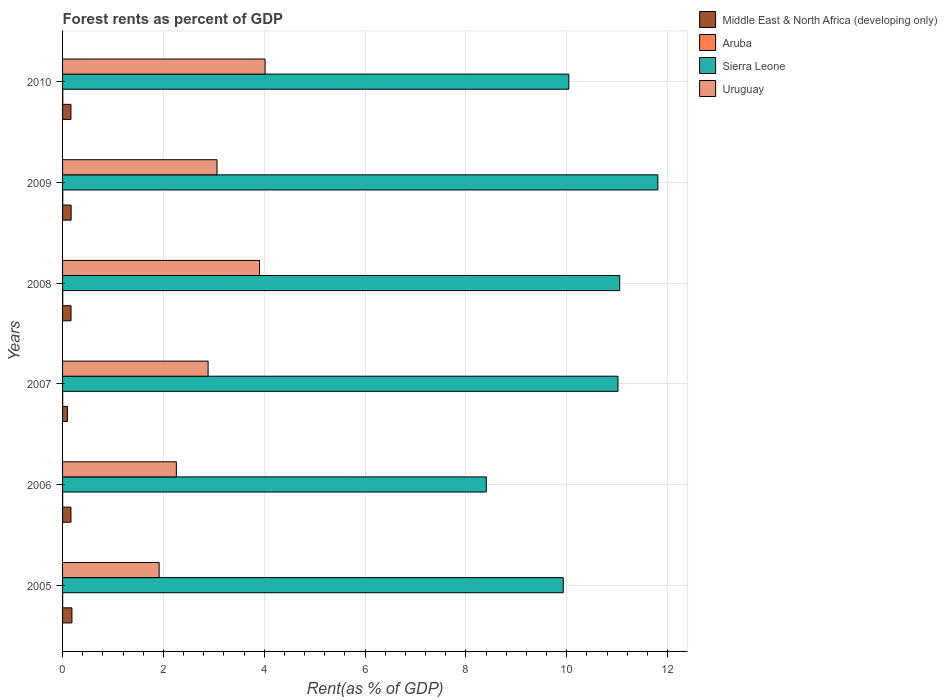Are the number of bars on each tick of the Y-axis equal?
Your answer should be compact. Yes. What is the label of the 5th group of bars from the top?
Ensure brevity in your answer.  2006. In how many cases, is the number of bars for a given year not equal to the number of legend labels?
Ensure brevity in your answer.  0. What is the forest rent in Middle East & North Africa (developing only) in 2005?
Offer a very short reply. 0.19. Across all years, what is the maximum forest rent in Middle East & North Africa (developing only)?
Your answer should be compact. 0.19. Across all years, what is the minimum forest rent in Uruguay?
Make the answer very short. 1.92. In which year was the forest rent in Middle East & North Africa (developing only) maximum?
Keep it short and to the point. 2005. In which year was the forest rent in Sierra Leone minimum?
Provide a short and direct response. 2006. What is the total forest rent in Aruba in the graph?
Offer a very short reply. 0.02. What is the difference between the forest rent in Sierra Leone in 2005 and that in 2008?
Provide a succinct answer. -1.12. What is the difference between the forest rent in Uruguay in 2006 and the forest rent in Sierra Leone in 2009?
Keep it short and to the point. -9.55. What is the average forest rent in Middle East & North Africa (developing only) per year?
Offer a terse response. 0.16. In the year 2005, what is the difference between the forest rent in Uruguay and forest rent in Sierra Leone?
Keep it short and to the point. -8.02. In how many years, is the forest rent in Sierra Leone greater than 9.2 %?
Make the answer very short. 5. What is the ratio of the forest rent in Middle East & North Africa (developing only) in 2006 to that in 2010?
Provide a short and direct response. 1. What is the difference between the highest and the second highest forest rent in Uruguay?
Offer a terse response. 0.11. What is the difference between the highest and the lowest forest rent in Uruguay?
Offer a very short reply. 2.1. In how many years, is the forest rent in Sierra Leone greater than the average forest rent in Sierra Leone taken over all years?
Ensure brevity in your answer.  3. What does the 4th bar from the top in 2006 represents?
Your answer should be compact. Middle East & North Africa (developing only). What does the 3rd bar from the bottom in 2008 represents?
Your answer should be very brief. Sierra Leone. How many bars are there?
Your answer should be very brief. 24. Are all the bars in the graph horizontal?
Offer a terse response. Yes. Are the values on the major ticks of X-axis written in scientific E-notation?
Your answer should be compact. No. Does the graph contain grids?
Offer a terse response. Yes. How many legend labels are there?
Make the answer very short. 4. What is the title of the graph?
Your response must be concise. Forest rents as percent of GDP. Does "Comoros" appear as one of the legend labels in the graph?
Offer a terse response. No. What is the label or title of the X-axis?
Give a very brief answer. Rent(as % of GDP). What is the label or title of the Y-axis?
Offer a terse response. Years. What is the Rent(as % of GDP) in Middle East & North Africa (developing only) in 2005?
Make the answer very short. 0.19. What is the Rent(as % of GDP) in Aruba in 2005?
Your response must be concise. 0. What is the Rent(as % of GDP) in Sierra Leone in 2005?
Offer a very short reply. 9.93. What is the Rent(as % of GDP) in Uruguay in 2005?
Your answer should be very brief. 1.92. What is the Rent(as % of GDP) in Middle East & North Africa (developing only) in 2006?
Provide a succinct answer. 0.17. What is the Rent(as % of GDP) in Aruba in 2006?
Provide a succinct answer. 0. What is the Rent(as % of GDP) of Sierra Leone in 2006?
Your answer should be very brief. 8.41. What is the Rent(as % of GDP) in Uruguay in 2006?
Provide a short and direct response. 2.26. What is the Rent(as % of GDP) in Middle East & North Africa (developing only) in 2007?
Keep it short and to the point. 0.1. What is the Rent(as % of GDP) in Aruba in 2007?
Provide a succinct answer. 0. What is the Rent(as % of GDP) in Sierra Leone in 2007?
Ensure brevity in your answer.  11.02. What is the Rent(as % of GDP) in Uruguay in 2007?
Ensure brevity in your answer.  2.89. What is the Rent(as % of GDP) in Middle East & North Africa (developing only) in 2008?
Your answer should be compact. 0.17. What is the Rent(as % of GDP) in Aruba in 2008?
Your answer should be compact. 0. What is the Rent(as % of GDP) of Sierra Leone in 2008?
Ensure brevity in your answer.  11.05. What is the Rent(as % of GDP) in Uruguay in 2008?
Your answer should be very brief. 3.91. What is the Rent(as % of GDP) in Middle East & North Africa (developing only) in 2009?
Provide a succinct answer. 0.17. What is the Rent(as % of GDP) of Aruba in 2009?
Your answer should be very brief. 0. What is the Rent(as % of GDP) of Sierra Leone in 2009?
Keep it short and to the point. 11.81. What is the Rent(as % of GDP) of Uruguay in 2009?
Provide a short and direct response. 3.06. What is the Rent(as % of GDP) of Middle East & North Africa (developing only) in 2010?
Your response must be concise. 0.17. What is the Rent(as % of GDP) in Aruba in 2010?
Keep it short and to the point. 0. What is the Rent(as % of GDP) in Sierra Leone in 2010?
Ensure brevity in your answer.  10.04. What is the Rent(as % of GDP) of Uruguay in 2010?
Ensure brevity in your answer.  4.02. Across all years, what is the maximum Rent(as % of GDP) of Middle East & North Africa (developing only)?
Give a very brief answer. 0.19. Across all years, what is the maximum Rent(as % of GDP) of Aruba?
Your answer should be very brief. 0. Across all years, what is the maximum Rent(as % of GDP) in Sierra Leone?
Keep it short and to the point. 11.81. Across all years, what is the maximum Rent(as % of GDP) of Uruguay?
Ensure brevity in your answer.  4.02. Across all years, what is the minimum Rent(as % of GDP) in Middle East & North Africa (developing only)?
Offer a terse response. 0.1. Across all years, what is the minimum Rent(as % of GDP) in Aruba?
Give a very brief answer. 0. Across all years, what is the minimum Rent(as % of GDP) of Sierra Leone?
Keep it short and to the point. 8.41. Across all years, what is the minimum Rent(as % of GDP) of Uruguay?
Ensure brevity in your answer.  1.92. What is the total Rent(as % of GDP) of Middle East & North Africa (developing only) in the graph?
Ensure brevity in your answer.  0.95. What is the total Rent(as % of GDP) of Aruba in the graph?
Your answer should be very brief. 0.02. What is the total Rent(as % of GDP) in Sierra Leone in the graph?
Keep it short and to the point. 62.26. What is the total Rent(as % of GDP) of Uruguay in the graph?
Provide a succinct answer. 18.05. What is the difference between the Rent(as % of GDP) in Middle East & North Africa (developing only) in 2005 and that in 2006?
Provide a short and direct response. 0.02. What is the difference between the Rent(as % of GDP) of Aruba in 2005 and that in 2006?
Your answer should be very brief. -0. What is the difference between the Rent(as % of GDP) in Sierra Leone in 2005 and that in 2006?
Keep it short and to the point. 1.53. What is the difference between the Rent(as % of GDP) in Uruguay in 2005 and that in 2006?
Your answer should be very brief. -0.34. What is the difference between the Rent(as % of GDP) in Middle East & North Africa (developing only) in 2005 and that in 2007?
Your answer should be compact. 0.09. What is the difference between the Rent(as % of GDP) of Aruba in 2005 and that in 2007?
Your answer should be very brief. -0. What is the difference between the Rent(as % of GDP) in Sierra Leone in 2005 and that in 2007?
Offer a very short reply. -1.09. What is the difference between the Rent(as % of GDP) in Uruguay in 2005 and that in 2007?
Provide a short and direct response. -0.97. What is the difference between the Rent(as % of GDP) of Middle East & North Africa (developing only) in 2005 and that in 2008?
Ensure brevity in your answer.  0.02. What is the difference between the Rent(as % of GDP) of Aruba in 2005 and that in 2008?
Provide a succinct answer. -0. What is the difference between the Rent(as % of GDP) in Sierra Leone in 2005 and that in 2008?
Your answer should be very brief. -1.12. What is the difference between the Rent(as % of GDP) in Uruguay in 2005 and that in 2008?
Your answer should be compact. -1.99. What is the difference between the Rent(as % of GDP) of Middle East & North Africa (developing only) in 2005 and that in 2009?
Your answer should be very brief. 0.02. What is the difference between the Rent(as % of GDP) in Aruba in 2005 and that in 2009?
Give a very brief answer. -0. What is the difference between the Rent(as % of GDP) of Sierra Leone in 2005 and that in 2009?
Offer a terse response. -1.88. What is the difference between the Rent(as % of GDP) in Uruguay in 2005 and that in 2009?
Give a very brief answer. -1.15. What is the difference between the Rent(as % of GDP) in Middle East & North Africa (developing only) in 2005 and that in 2010?
Give a very brief answer. 0.02. What is the difference between the Rent(as % of GDP) in Aruba in 2005 and that in 2010?
Your response must be concise. -0. What is the difference between the Rent(as % of GDP) in Sierra Leone in 2005 and that in 2010?
Provide a short and direct response. -0.11. What is the difference between the Rent(as % of GDP) of Uruguay in 2005 and that in 2010?
Give a very brief answer. -2.1. What is the difference between the Rent(as % of GDP) in Middle East & North Africa (developing only) in 2006 and that in 2007?
Provide a succinct answer. 0.07. What is the difference between the Rent(as % of GDP) in Aruba in 2006 and that in 2007?
Ensure brevity in your answer.  -0. What is the difference between the Rent(as % of GDP) of Sierra Leone in 2006 and that in 2007?
Make the answer very short. -2.61. What is the difference between the Rent(as % of GDP) of Uruguay in 2006 and that in 2007?
Ensure brevity in your answer.  -0.63. What is the difference between the Rent(as % of GDP) of Middle East & North Africa (developing only) in 2006 and that in 2008?
Give a very brief answer. -0. What is the difference between the Rent(as % of GDP) of Aruba in 2006 and that in 2008?
Offer a terse response. -0. What is the difference between the Rent(as % of GDP) in Sierra Leone in 2006 and that in 2008?
Make the answer very short. -2.65. What is the difference between the Rent(as % of GDP) of Uruguay in 2006 and that in 2008?
Offer a very short reply. -1.65. What is the difference between the Rent(as % of GDP) in Middle East & North Africa (developing only) in 2006 and that in 2009?
Keep it short and to the point. -0. What is the difference between the Rent(as % of GDP) of Aruba in 2006 and that in 2009?
Provide a short and direct response. -0. What is the difference between the Rent(as % of GDP) in Sierra Leone in 2006 and that in 2009?
Ensure brevity in your answer.  -3.4. What is the difference between the Rent(as % of GDP) in Uruguay in 2006 and that in 2009?
Make the answer very short. -0.81. What is the difference between the Rent(as % of GDP) of Aruba in 2006 and that in 2010?
Ensure brevity in your answer.  -0. What is the difference between the Rent(as % of GDP) of Sierra Leone in 2006 and that in 2010?
Your answer should be very brief. -1.64. What is the difference between the Rent(as % of GDP) of Uruguay in 2006 and that in 2010?
Provide a short and direct response. -1.76. What is the difference between the Rent(as % of GDP) in Middle East & North Africa (developing only) in 2007 and that in 2008?
Your answer should be very brief. -0.07. What is the difference between the Rent(as % of GDP) of Aruba in 2007 and that in 2008?
Your answer should be very brief. -0. What is the difference between the Rent(as % of GDP) in Sierra Leone in 2007 and that in 2008?
Offer a terse response. -0.03. What is the difference between the Rent(as % of GDP) of Uruguay in 2007 and that in 2008?
Provide a short and direct response. -1.02. What is the difference between the Rent(as % of GDP) of Middle East & North Africa (developing only) in 2007 and that in 2009?
Keep it short and to the point. -0.07. What is the difference between the Rent(as % of GDP) of Aruba in 2007 and that in 2009?
Ensure brevity in your answer.  -0. What is the difference between the Rent(as % of GDP) in Sierra Leone in 2007 and that in 2009?
Keep it short and to the point. -0.79. What is the difference between the Rent(as % of GDP) of Uruguay in 2007 and that in 2009?
Offer a very short reply. -0.18. What is the difference between the Rent(as % of GDP) of Middle East & North Africa (developing only) in 2007 and that in 2010?
Provide a short and direct response. -0.07. What is the difference between the Rent(as % of GDP) of Aruba in 2007 and that in 2010?
Your response must be concise. -0. What is the difference between the Rent(as % of GDP) in Sierra Leone in 2007 and that in 2010?
Your answer should be compact. 0.98. What is the difference between the Rent(as % of GDP) in Uruguay in 2007 and that in 2010?
Provide a short and direct response. -1.13. What is the difference between the Rent(as % of GDP) in Middle East & North Africa (developing only) in 2008 and that in 2009?
Your answer should be compact. -0. What is the difference between the Rent(as % of GDP) of Aruba in 2008 and that in 2009?
Your answer should be very brief. -0. What is the difference between the Rent(as % of GDP) in Sierra Leone in 2008 and that in 2009?
Provide a short and direct response. -0.76. What is the difference between the Rent(as % of GDP) of Uruguay in 2008 and that in 2009?
Provide a succinct answer. 0.84. What is the difference between the Rent(as % of GDP) of Middle East & North Africa (developing only) in 2008 and that in 2010?
Keep it short and to the point. 0. What is the difference between the Rent(as % of GDP) in Aruba in 2008 and that in 2010?
Give a very brief answer. -0. What is the difference between the Rent(as % of GDP) in Sierra Leone in 2008 and that in 2010?
Keep it short and to the point. 1.01. What is the difference between the Rent(as % of GDP) of Uruguay in 2008 and that in 2010?
Give a very brief answer. -0.11. What is the difference between the Rent(as % of GDP) in Middle East & North Africa (developing only) in 2009 and that in 2010?
Your response must be concise. 0. What is the difference between the Rent(as % of GDP) in Aruba in 2009 and that in 2010?
Provide a succinct answer. -0. What is the difference between the Rent(as % of GDP) in Sierra Leone in 2009 and that in 2010?
Ensure brevity in your answer.  1.77. What is the difference between the Rent(as % of GDP) of Uruguay in 2009 and that in 2010?
Keep it short and to the point. -0.95. What is the difference between the Rent(as % of GDP) in Middle East & North Africa (developing only) in 2005 and the Rent(as % of GDP) in Aruba in 2006?
Your response must be concise. 0.18. What is the difference between the Rent(as % of GDP) in Middle East & North Africa (developing only) in 2005 and the Rent(as % of GDP) in Sierra Leone in 2006?
Give a very brief answer. -8.22. What is the difference between the Rent(as % of GDP) in Middle East & North Africa (developing only) in 2005 and the Rent(as % of GDP) in Uruguay in 2006?
Give a very brief answer. -2.07. What is the difference between the Rent(as % of GDP) in Aruba in 2005 and the Rent(as % of GDP) in Sierra Leone in 2006?
Offer a very short reply. -8.4. What is the difference between the Rent(as % of GDP) in Aruba in 2005 and the Rent(as % of GDP) in Uruguay in 2006?
Your answer should be very brief. -2.26. What is the difference between the Rent(as % of GDP) in Sierra Leone in 2005 and the Rent(as % of GDP) in Uruguay in 2006?
Make the answer very short. 7.68. What is the difference between the Rent(as % of GDP) in Middle East & North Africa (developing only) in 2005 and the Rent(as % of GDP) in Aruba in 2007?
Provide a succinct answer. 0.18. What is the difference between the Rent(as % of GDP) of Middle East & North Africa (developing only) in 2005 and the Rent(as % of GDP) of Sierra Leone in 2007?
Make the answer very short. -10.83. What is the difference between the Rent(as % of GDP) in Middle East & North Africa (developing only) in 2005 and the Rent(as % of GDP) in Uruguay in 2007?
Make the answer very short. -2.7. What is the difference between the Rent(as % of GDP) of Aruba in 2005 and the Rent(as % of GDP) of Sierra Leone in 2007?
Keep it short and to the point. -11.02. What is the difference between the Rent(as % of GDP) of Aruba in 2005 and the Rent(as % of GDP) of Uruguay in 2007?
Your response must be concise. -2.89. What is the difference between the Rent(as % of GDP) in Sierra Leone in 2005 and the Rent(as % of GDP) in Uruguay in 2007?
Give a very brief answer. 7.05. What is the difference between the Rent(as % of GDP) in Middle East & North Africa (developing only) in 2005 and the Rent(as % of GDP) in Aruba in 2008?
Your answer should be compact. 0.18. What is the difference between the Rent(as % of GDP) in Middle East & North Africa (developing only) in 2005 and the Rent(as % of GDP) in Sierra Leone in 2008?
Your answer should be very brief. -10.87. What is the difference between the Rent(as % of GDP) of Middle East & North Africa (developing only) in 2005 and the Rent(as % of GDP) of Uruguay in 2008?
Offer a terse response. -3.72. What is the difference between the Rent(as % of GDP) of Aruba in 2005 and the Rent(as % of GDP) of Sierra Leone in 2008?
Your response must be concise. -11.05. What is the difference between the Rent(as % of GDP) in Aruba in 2005 and the Rent(as % of GDP) in Uruguay in 2008?
Give a very brief answer. -3.91. What is the difference between the Rent(as % of GDP) of Sierra Leone in 2005 and the Rent(as % of GDP) of Uruguay in 2008?
Your response must be concise. 6.03. What is the difference between the Rent(as % of GDP) of Middle East & North Africa (developing only) in 2005 and the Rent(as % of GDP) of Aruba in 2009?
Give a very brief answer. 0.18. What is the difference between the Rent(as % of GDP) in Middle East & North Africa (developing only) in 2005 and the Rent(as % of GDP) in Sierra Leone in 2009?
Offer a very short reply. -11.62. What is the difference between the Rent(as % of GDP) in Middle East & North Africa (developing only) in 2005 and the Rent(as % of GDP) in Uruguay in 2009?
Provide a succinct answer. -2.88. What is the difference between the Rent(as % of GDP) in Aruba in 2005 and the Rent(as % of GDP) in Sierra Leone in 2009?
Provide a short and direct response. -11.81. What is the difference between the Rent(as % of GDP) of Aruba in 2005 and the Rent(as % of GDP) of Uruguay in 2009?
Provide a short and direct response. -3.06. What is the difference between the Rent(as % of GDP) of Sierra Leone in 2005 and the Rent(as % of GDP) of Uruguay in 2009?
Offer a very short reply. 6.87. What is the difference between the Rent(as % of GDP) of Middle East & North Africa (developing only) in 2005 and the Rent(as % of GDP) of Aruba in 2010?
Offer a very short reply. 0.18. What is the difference between the Rent(as % of GDP) of Middle East & North Africa (developing only) in 2005 and the Rent(as % of GDP) of Sierra Leone in 2010?
Your answer should be very brief. -9.86. What is the difference between the Rent(as % of GDP) of Middle East & North Africa (developing only) in 2005 and the Rent(as % of GDP) of Uruguay in 2010?
Provide a succinct answer. -3.83. What is the difference between the Rent(as % of GDP) of Aruba in 2005 and the Rent(as % of GDP) of Sierra Leone in 2010?
Your answer should be very brief. -10.04. What is the difference between the Rent(as % of GDP) in Aruba in 2005 and the Rent(as % of GDP) in Uruguay in 2010?
Make the answer very short. -4.02. What is the difference between the Rent(as % of GDP) of Sierra Leone in 2005 and the Rent(as % of GDP) of Uruguay in 2010?
Ensure brevity in your answer.  5.92. What is the difference between the Rent(as % of GDP) in Middle East & North Africa (developing only) in 2006 and the Rent(as % of GDP) in Aruba in 2007?
Keep it short and to the point. 0.16. What is the difference between the Rent(as % of GDP) in Middle East & North Africa (developing only) in 2006 and the Rent(as % of GDP) in Sierra Leone in 2007?
Provide a succinct answer. -10.85. What is the difference between the Rent(as % of GDP) of Middle East & North Africa (developing only) in 2006 and the Rent(as % of GDP) of Uruguay in 2007?
Make the answer very short. -2.72. What is the difference between the Rent(as % of GDP) of Aruba in 2006 and the Rent(as % of GDP) of Sierra Leone in 2007?
Offer a terse response. -11.02. What is the difference between the Rent(as % of GDP) of Aruba in 2006 and the Rent(as % of GDP) of Uruguay in 2007?
Your response must be concise. -2.89. What is the difference between the Rent(as % of GDP) of Sierra Leone in 2006 and the Rent(as % of GDP) of Uruguay in 2007?
Give a very brief answer. 5.52. What is the difference between the Rent(as % of GDP) of Middle East & North Africa (developing only) in 2006 and the Rent(as % of GDP) of Aruba in 2008?
Your answer should be compact. 0.16. What is the difference between the Rent(as % of GDP) of Middle East & North Africa (developing only) in 2006 and the Rent(as % of GDP) of Sierra Leone in 2008?
Your answer should be compact. -10.89. What is the difference between the Rent(as % of GDP) of Middle East & North Africa (developing only) in 2006 and the Rent(as % of GDP) of Uruguay in 2008?
Your answer should be compact. -3.74. What is the difference between the Rent(as % of GDP) in Aruba in 2006 and the Rent(as % of GDP) in Sierra Leone in 2008?
Make the answer very short. -11.05. What is the difference between the Rent(as % of GDP) in Aruba in 2006 and the Rent(as % of GDP) in Uruguay in 2008?
Provide a succinct answer. -3.9. What is the difference between the Rent(as % of GDP) in Sierra Leone in 2006 and the Rent(as % of GDP) in Uruguay in 2008?
Offer a very short reply. 4.5. What is the difference between the Rent(as % of GDP) in Middle East & North Africa (developing only) in 2006 and the Rent(as % of GDP) in Aruba in 2009?
Keep it short and to the point. 0.16. What is the difference between the Rent(as % of GDP) of Middle East & North Africa (developing only) in 2006 and the Rent(as % of GDP) of Sierra Leone in 2009?
Provide a succinct answer. -11.64. What is the difference between the Rent(as % of GDP) of Middle East & North Africa (developing only) in 2006 and the Rent(as % of GDP) of Uruguay in 2009?
Offer a terse response. -2.9. What is the difference between the Rent(as % of GDP) of Aruba in 2006 and the Rent(as % of GDP) of Sierra Leone in 2009?
Your answer should be compact. -11.81. What is the difference between the Rent(as % of GDP) of Aruba in 2006 and the Rent(as % of GDP) of Uruguay in 2009?
Your response must be concise. -3.06. What is the difference between the Rent(as % of GDP) in Sierra Leone in 2006 and the Rent(as % of GDP) in Uruguay in 2009?
Offer a very short reply. 5.34. What is the difference between the Rent(as % of GDP) of Middle East & North Africa (developing only) in 2006 and the Rent(as % of GDP) of Aruba in 2010?
Ensure brevity in your answer.  0.16. What is the difference between the Rent(as % of GDP) of Middle East & North Africa (developing only) in 2006 and the Rent(as % of GDP) of Sierra Leone in 2010?
Your response must be concise. -9.88. What is the difference between the Rent(as % of GDP) of Middle East & North Africa (developing only) in 2006 and the Rent(as % of GDP) of Uruguay in 2010?
Your answer should be very brief. -3.85. What is the difference between the Rent(as % of GDP) in Aruba in 2006 and the Rent(as % of GDP) in Sierra Leone in 2010?
Provide a short and direct response. -10.04. What is the difference between the Rent(as % of GDP) of Aruba in 2006 and the Rent(as % of GDP) of Uruguay in 2010?
Provide a succinct answer. -4.02. What is the difference between the Rent(as % of GDP) in Sierra Leone in 2006 and the Rent(as % of GDP) in Uruguay in 2010?
Ensure brevity in your answer.  4.39. What is the difference between the Rent(as % of GDP) in Middle East & North Africa (developing only) in 2007 and the Rent(as % of GDP) in Aruba in 2008?
Ensure brevity in your answer.  0.09. What is the difference between the Rent(as % of GDP) in Middle East & North Africa (developing only) in 2007 and the Rent(as % of GDP) in Sierra Leone in 2008?
Offer a terse response. -10.96. What is the difference between the Rent(as % of GDP) of Middle East & North Africa (developing only) in 2007 and the Rent(as % of GDP) of Uruguay in 2008?
Provide a short and direct response. -3.81. What is the difference between the Rent(as % of GDP) in Aruba in 2007 and the Rent(as % of GDP) in Sierra Leone in 2008?
Ensure brevity in your answer.  -11.05. What is the difference between the Rent(as % of GDP) in Aruba in 2007 and the Rent(as % of GDP) in Uruguay in 2008?
Provide a short and direct response. -3.9. What is the difference between the Rent(as % of GDP) in Sierra Leone in 2007 and the Rent(as % of GDP) in Uruguay in 2008?
Offer a terse response. 7.11. What is the difference between the Rent(as % of GDP) in Middle East & North Africa (developing only) in 2007 and the Rent(as % of GDP) in Aruba in 2009?
Ensure brevity in your answer.  0.09. What is the difference between the Rent(as % of GDP) in Middle East & North Africa (developing only) in 2007 and the Rent(as % of GDP) in Sierra Leone in 2009?
Ensure brevity in your answer.  -11.71. What is the difference between the Rent(as % of GDP) of Middle East & North Africa (developing only) in 2007 and the Rent(as % of GDP) of Uruguay in 2009?
Keep it short and to the point. -2.97. What is the difference between the Rent(as % of GDP) in Aruba in 2007 and the Rent(as % of GDP) in Sierra Leone in 2009?
Your response must be concise. -11.81. What is the difference between the Rent(as % of GDP) of Aruba in 2007 and the Rent(as % of GDP) of Uruguay in 2009?
Give a very brief answer. -3.06. What is the difference between the Rent(as % of GDP) in Sierra Leone in 2007 and the Rent(as % of GDP) in Uruguay in 2009?
Your response must be concise. 7.95. What is the difference between the Rent(as % of GDP) in Middle East & North Africa (developing only) in 2007 and the Rent(as % of GDP) in Aruba in 2010?
Provide a short and direct response. 0.09. What is the difference between the Rent(as % of GDP) in Middle East & North Africa (developing only) in 2007 and the Rent(as % of GDP) in Sierra Leone in 2010?
Your response must be concise. -9.95. What is the difference between the Rent(as % of GDP) of Middle East & North Africa (developing only) in 2007 and the Rent(as % of GDP) of Uruguay in 2010?
Ensure brevity in your answer.  -3.92. What is the difference between the Rent(as % of GDP) of Aruba in 2007 and the Rent(as % of GDP) of Sierra Leone in 2010?
Keep it short and to the point. -10.04. What is the difference between the Rent(as % of GDP) in Aruba in 2007 and the Rent(as % of GDP) in Uruguay in 2010?
Give a very brief answer. -4.01. What is the difference between the Rent(as % of GDP) of Sierra Leone in 2007 and the Rent(as % of GDP) of Uruguay in 2010?
Make the answer very short. 7. What is the difference between the Rent(as % of GDP) in Middle East & North Africa (developing only) in 2008 and the Rent(as % of GDP) in Aruba in 2009?
Your answer should be compact. 0.16. What is the difference between the Rent(as % of GDP) of Middle East & North Africa (developing only) in 2008 and the Rent(as % of GDP) of Sierra Leone in 2009?
Give a very brief answer. -11.64. What is the difference between the Rent(as % of GDP) in Middle East & North Africa (developing only) in 2008 and the Rent(as % of GDP) in Uruguay in 2009?
Your answer should be compact. -2.9. What is the difference between the Rent(as % of GDP) of Aruba in 2008 and the Rent(as % of GDP) of Sierra Leone in 2009?
Offer a terse response. -11.8. What is the difference between the Rent(as % of GDP) in Aruba in 2008 and the Rent(as % of GDP) in Uruguay in 2009?
Your answer should be compact. -3.06. What is the difference between the Rent(as % of GDP) of Sierra Leone in 2008 and the Rent(as % of GDP) of Uruguay in 2009?
Provide a short and direct response. 7.99. What is the difference between the Rent(as % of GDP) in Middle East & North Africa (developing only) in 2008 and the Rent(as % of GDP) in Aruba in 2010?
Your answer should be compact. 0.16. What is the difference between the Rent(as % of GDP) of Middle East & North Africa (developing only) in 2008 and the Rent(as % of GDP) of Sierra Leone in 2010?
Give a very brief answer. -9.87. What is the difference between the Rent(as % of GDP) in Middle East & North Africa (developing only) in 2008 and the Rent(as % of GDP) in Uruguay in 2010?
Ensure brevity in your answer.  -3.85. What is the difference between the Rent(as % of GDP) in Aruba in 2008 and the Rent(as % of GDP) in Sierra Leone in 2010?
Give a very brief answer. -10.04. What is the difference between the Rent(as % of GDP) of Aruba in 2008 and the Rent(as % of GDP) of Uruguay in 2010?
Provide a short and direct response. -4.01. What is the difference between the Rent(as % of GDP) in Sierra Leone in 2008 and the Rent(as % of GDP) in Uruguay in 2010?
Offer a terse response. 7.03. What is the difference between the Rent(as % of GDP) of Middle East & North Africa (developing only) in 2009 and the Rent(as % of GDP) of Aruba in 2010?
Your answer should be compact. 0.17. What is the difference between the Rent(as % of GDP) of Middle East & North Africa (developing only) in 2009 and the Rent(as % of GDP) of Sierra Leone in 2010?
Your answer should be very brief. -9.87. What is the difference between the Rent(as % of GDP) of Middle East & North Africa (developing only) in 2009 and the Rent(as % of GDP) of Uruguay in 2010?
Give a very brief answer. -3.85. What is the difference between the Rent(as % of GDP) in Aruba in 2009 and the Rent(as % of GDP) in Sierra Leone in 2010?
Provide a succinct answer. -10.04. What is the difference between the Rent(as % of GDP) of Aruba in 2009 and the Rent(as % of GDP) of Uruguay in 2010?
Offer a terse response. -4.01. What is the difference between the Rent(as % of GDP) of Sierra Leone in 2009 and the Rent(as % of GDP) of Uruguay in 2010?
Offer a very short reply. 7.79. What is the average Rent(as % of GDP) in Middle East & North Africa (developing only) per year?
Give a very brief answer. 0.16. What is the average Rent(as % of GDP) in Aruba per year?
Ensure brevity in your answer.  0. What is the average Rent(as % of GDP) of Sierra Leone per year?
Give a very brief answer. 10.38. What is the average Rent(as % of GDP) of Uruguay per year?
Provide a succinct answer. 3.01. In the year 2005, what is the difference between the Rent(as % of GDP) of Middle East & North Africa (developing only) and Rent(as % of GDP) of Aruba?
Offer a terse response. 0.18. In the year 2005, what is the difference between the Rent(as % of GDP) in Middle East & North Africa (developing only) and Rent(as % of GDP) in Sierra Leone?
Provide a short and direct response. -9.75. In the year 2005, what is the difference between the Rent(as % of GDP) of Middle East & North Africa (developing only) and Rent(as % of GDP) of Uruguay?
Offer a very short reply. -1.73. In the year 2005, what is the difference between the Rent(as % of GDP) in Aruba and Rent(as % of GDP) in Sierra Leone?
Provide a succinct answer. -9.93. In the year 2005, what is the difference between the Rent(as % of GDP) of Aruba and Rent(as % of GDP) of Uruguay?
Give a very brief answer. -1.91. In the year 2005, what is the difference between the Rent(as % of GDP) of Sierra Leone and Rent(as % of GDP) of Uruguay?
Keep it short and to the point. 8.02. In the year 2006, what is the difference between the Rent(as % of GDP) in Middle East & North Africa (developing only) and Rent(as % of GDP) in Aruba?
Your response must be concise. 0.16. In the year 2006, what is the difference between the Rent(as % of GDP) in Middle East & North Africa (developing only) and Rent(as % of GDP) in Sierra Leone?
Ensure brevity in your answer.  -8.24. In the year 2006, what is the difference between the Rent(as % of GDP) in Middle East & North Africa (developing only) and Rent(as % of GDP) in Uruguay?
Provide a succinct answer. -2.09. In the year 2006, what is the difference between the Rent(as % of GDP) in Aruba and Rent(as % of GDP) in Sierra Leone?
Your answer should be compact. -8.4. In the year 2006, what is the difference between the Rent(as % of GDP) of Aruba and Rent(as % of GDP) of Uruguay?
Offer a very short reply. -2.26. In the year 2006, what is the difference between the Rent(as % of GDP) of Sierra Leone and Rent(as % of GDP) of Uruguay?
Give a very brief answer. 6.15. In the year 2007, what is the difference between the Rent(as % of GDP) of Middle East & North Africa (developing only) and Rent(as % of GDP) of Aruba?
Provide a succinct answer. 0.09. In the year 2007, what is the difference between the Rent(as % of GDP) in Middle East & North Africa (developing only) and Rent(as % of GDP) in Sierra Leone?
Provide a short and direct response. -10.92. In the year 2007, what is the difference between the Rent(as % of GDP) in Middle East & North Africa (developing only) and Rent(as % of GDP) in Uruguay?
Make the answer very short. -2.79. In the year 2007, what is the difference between the Rent(as % of GDP) of Aruba and Rent(as % of GDP) of Sierra Leone?
Keep it short and to the point. -11.02. In the year 2007, what is the difference between the Rent(as % of GDP) of Aruba and Rent(as % of GDP) of Uruguay?
Your response must be concise. -2.88. In the year 2007, what is the difference between the Rent(as % of GDP) of Sierra Leone and Rent(as % of GDP) of Uruguay?
Offer a very short reply. 8.13. In the year 2008, what is the difference between the Rent(as % of GDP) in Middle East & North Africa (developing only) and Rent(as % of GDP) in Aruba?
Ensure brevity in your answer.  0.16. In the year 2008, what is the difference between the Rent(as % of GDP) in Middle East & North Africa (developing only) and Rent(as % of GDP) in Sierra Leone?
Provide a succinct answer. -10.88. In the year 2008, what is the difference between the Rent(as % of GDP) of Middle East & North Africa (developing only) and Rent(as % of GDP) of Uruguay?
Give a very brief answer. -3.74. In the year 2008, what is the difference between the Rent(as % of GDP) of Aruba and Rent(as % of GDP) of Sierra Leone?
Your response must be concise. -11.05. In the year 2008, what is the difference between the Rent(as % of GDP) in Aruba and Rent(as % of GDP) in Uruguay?
Give a very brief answer. -3.9. In the year 2008, what is the difference between the Rent(as % of GDP) of Sierra Leone and Rent(as % of GDP) of Uruguay?
Give a very brief answer. 7.14. In the year 2009, what is the difference between the Rent(as % of GDP) in Middle East & North Africa (developing only) and Rent(as % of GDP) in Aruba?
Offer a terse response. 0.17. In the year 2009, what is the difference between the Rent(as % of GDP) in Middle East & North Africa (developing only) and Rent(as % of GDP) in Sierra Leone?
Ensure brevity in your answer.  -11.64. In the year 2009, what is the difference between the Rent(as % of GDP) in Middle East & North Africa (developing only) and Rent(as % of GDP) in Uruguay?
Your response must be concise. -2.89. In the year 2009, what is the difference between the Rent(as % of GDP) of Aruba and Rent(as % of GDP) of Sierra Leone?
Your answer should be very brief. -11.8. In the year 2009, what is the difference between the Rent(as % of GDP) in Aruba and Rent(as % of GDP) in Uruguay?
Make the answer very short. -3.06. In the year 2009, what is the difference between the Rent(as % of GDP) in Sierra Leone and Rent(as % of GDP) in Uruguay?
Your answer should be very brief. 8.74. In the year 2010, what is the difference between the Rent(as % of GDP) of Middle East & North Africa (developing only) and Rent(as % of GDP) of Aruba?
Give a very brief answer. 0.16. In the year 2010, what is the difference between the Rent(as % of GDP) of Middle East & North Africa (developing only) and Rent(as % of GDP) of Sierra Leone?
Give a very brief answer. -9.88. In the year 2010, what is the difference between the Rent(as % of GDP) in Middle East & North Africa (developing only) and Rent(as % of GDP) in Uruguay?
Give a very brief answer. -3.85. In the year 2010, what is the difference between the Rent(as % of GDP) of Aruba and Rent(as % of GDP) of Sierra Leone?
Ensure brevity in your answer.  -10.04. In the year 2010, what is the difference between the Rent(as % of GDP) of Aruba and Rent(as % of GDP) of Uruguay?
Keep it short and to the point. -4.01. In the year 2010, what is the difference between the Rent(as % of GDP) in Sierra Leone and Rent(as % of GDP) in Uruguay?
Keep it short and to the point. 6.03. What is the ratio of the Rent(as % of GDP) of Middle East & North Africa (developing only) in 2005 to that in 2006?
Ensure brevity in your answer.  1.12. What is the ratio of the Rent(as % of GDP) in Aruba in 2005 to that in 2006?
Offer a terse response. 0.79. What is the ratio of the Rent(as % of GDP) of Sierra Leone in 2005 to that in 2006?
Keep it short and to the point. 1.18. What is the ratio of the Rent(as % of GDP) of Uruguay in 2005 to that in 2006?
Keep it short and to the point. 0.85. What is the ratio of the Rent(as % of GDP) of Middle East & North Africa (developing only) in 2005 to that in 2007?
Your answer should be compact. 1.93. What is the ratio of the Rent(as % of GDP) in Aruba in 2005 to that in 2007?
Keep it short and to the point. 0.61. What is the ratio of the Rent(as % of GDP) in Sierra Leone in 2005 to that in 2007?
Keep it short and to the point. 0.9. What is the ratio of the Rent(as % of GDP) of Uruguay in 2005 to that in 2007?
Provide a succinct answer. 0.66. What is the ratio of the Rent(as % of GDP) in Middle East & North Africa (developing only) in 2005 to that in 2008?
Give a very brief answer. 1.11. What is the ratio of the Rent(as % of GDP) of Aruba in 2005 to that in 2008?
Your answer should be very brief. 0.46. What is the ratio of the Rent(as % of GDP) of Sierra Leone in 2005 to that in 2008?
Give a very brief answer. 0.9. What is the ratio of the Rent(as % of GDP) in Uruguay in 2005 to that in 2008?
Offer a very short reply. 0.49. What is the ratio of the Rent(as % of GDP) in Middle East & North Africa (developing only) in 2005 to that in 2009?
Your answer should be compact. 1.09. What is the ratio of the Rent(as % of GDP) in Aruba in 2005 to that in 2009?
Provide a short and direct response. 0.43. What is the ratio of the Rent(as % of GDP) in Sierra Leone in 2005 to that in 2009?
Provide a short and direct response. 0.84. What is the ratio of the Rent(as % of GDP) in Uruguay in 2005 to that in 2009?
Your response must be concise. 0.63. What is the ratio of the Rent(as % of GDP) of Middle East & North Africa (developing only) in 2005 to that in 2010?
Give a very brief answer. 1.12. What is the ratio of the Rent(as % of GDP) of Aruba in 2005 to that in 2010?
Offer a terse response. 0.33. What is the ratio of the Rent(as % of GDP) in Sierra Leone in 2005 to that in 2010?
Keep it short and to the point. 0.99. What is the ratio of the Rent(as % of GDP) in Uruguay in 2005 to that in 2010?
Ensure brevity in your answer.  0.48. What is the ratio of the Rent(as % of GDP) of Middle East & North Africa (developing only) in 2006 to that in 2007?
Make the answer very short. 1.73. What is the ratio of the Rent(as % of GDP) of Aruba in 2006 to that in 2007?
Provide a succinct answer. 0.77. What is the ratio of the Rent(as % of GDP) of Sierra Leone in 2006 to that in 2007?
Keep it short and to the point. 0.76. What is the ratio of the Rent(as % of GDP) in Uruguay in 2006 to that in 2007?
Your answer should be compact. 0.78. What is the ratio of the Rent(as % of GDP) in Middle East & North Africa (developing only) in 2006 to that in 2008?
Offer a very short reply. 0.99. What is the ratio of the Rent(as % of GDP) of Aruba in 2006 to that in 2008?
Provide a short and direct response. 0.58. What is the ratio of the Rent(as % of GDP) in Sierra Leone in 2006 to that in 2008?
Keep it short and to the point. 0.76. What is the ratio of the Rent(as % of GDP) in Uruguay in 2006 to that in 2008?
Offer a very short reply. 0.58. What is the ratio of the Rent(as % of GDP) of Middle East & North Africa (developing only) in 2006 to that in 2009?
Offer a terse response. 0.98. What is the ratio of the Rent(as % of GDP) in Aruba in 2006 to that in 2009?
Give a very brief answer. 0.55. What is the ratio of the Rent(as % of GDP) in Sierra Leone in 2006 to that in 2009?
Provide a succinct answer. 0.71. What is the ratio of the Rent(as % of GDP) in Uruguay in 2006 to that in 2009?
Your answer should be compact. 0.74. What is the ratio of the Rent(as % of GDP) in Aruba in 2006 to that in 2010?
Your response must be concise. 0.42. What is the ratio of the Rent(as % of GDP) of Sierra Leone in 2006 to that in 2010?
Ensure brevity in your answer.  0.84. What is the ratio of the Rent(as % of GDP) of Uruguay in 2006 to that in 2010?
Ensure brevity in your answer.  0.56. What is the ratio of the Rent(as % of GDP) of Middle East & North Africa (developing only) in 2007 to that in 2008?
Make the answer very short. 0.57. What is the ratio of the Rent(as % of GDP) in Aruba in 2007 to that in 2008?
Make the answer very short. 0.76. What is the ratio of the Rent(as % of GDP) of Sierra Leone in 2007 to that in 2008?
Give a very brief answer. 1. What is the ratio of the Rent(as % of GDP) of Uruguay in 2007 to that in 2008?
Make the answer very short. 0.74. What is the ratio of the Rent(as % of GDP) of Middle East & North Africa (developing only) in 2007 to that in 2009?
Ensure brevity in your answer.  0.57. What is the ratio of the Rent(as % of GDP) of Aruba in 2007 to that in 2009?
Your response must be concise. 0.71. What is the ratio of the Rent(as % of GDP) in Sierra Leone in 2007 to that in 2009?
Ensure brevity in your answer.  0.93. What is the ratio of the Rent(as % of GDP) in Uruguay in 2007 to that in 2009?
Your answer should be compact. 0.94. What is the ratio of the Rent(as % of GDP) in Middle East & North Africa (developing only) in 2007 to that in 2010?
Keep it short and to the point. 0.58. What is the ratio of the Rent(as % of GDP) of Aruba in 2007 to that in 2010?
Offer a terse response. 0.55. What is the ratio of the Rent(as % of GDP) of Sierra Leone in 2007 to that in 2010?
Ensure brevity in your answer.  1.1. What is the ratio of the Rent(as % of GDP) in Uruguay in 2007 to that in 2010?
Offer a terse response. 0.72. What is the ratio of the Rent(as % of GDP) of Aruba in 2008 to that in 2009?
Your response must be concise. 0.94. What is the ratio of the Rent(as % of GDP) in Sierra Leone in 2008 to that in 2009?
Keep it short and to the point. 0.94. What is the ratio of the Rent(as % of GDP) in Uruguay in 2008 to that in 2009?
Ensure brevity in your answer.  1.27. What is the ratio of the Rent(as % of GDP) of Middle East & North Africa (developing only) in 2008 to that in 2010?
Make the answer very short. 1.01. What is the ratio of the Rent(as % of GDP) of Aruba in 2008 to that in 2010?
Your answer should be very brief. 0.72. What is the ratio of the Rent(as % of GDP) in Sierra Leone in 2008 to that in 2010?
Provide a short and direct response. 1.1. What is the ratio of the Rent(as % of GDP) in Uruguay in 2008 to that in 2010?
Keep it short and to the point. 0.97. What is the ratio of the Rent(as % of GDP) of Aruba in 2009 to that in 2010?
Keep it short and to the point. 0.77. What is the ratio of the Rent(as % of GDP) of Sierra Leone in 2009 to that in 2010?
Provide a succinct answer. 1.18. What is the ratio of the Rent(as % of GDP) of Uruguay in 2009 to that in 2010?
Make the answer very short. 0.76. What is the difference between the highest and the second highest Rent(as % of GDP) of Middle East & North Africa (developing only)?
Provide a succinct answer. 0.02. What is the difference between the highest and the second highest Rent(as % of GDP) in Aruba?
Keep it short and to the point. 0. What is the difference between the highest and the second highest Rent(as % of GDP) in Sierra Leone?
Your response must be concise. 0.76. What is the difference between the highest and the second highest Rent(as % of GDP) of Uruguay?
Ensure brevity in your answer.  0.11. What is the difference between the highest and the lowest Rent(as % of GDP) of Middle East & North Africa (developing only)?
Offer a very short reply. 0.09. What is the difference between the highest and the lowest Rent(as % of GDP) of Aruba?
Provide a short and direct response. 0. What is the difference between the highest and the lowest Rent(as % of GDP) in Sierra Leone?
Your answer should be compact. 3.4. What is the difference between the highest and the lowest Rent(as % of GDP) of Uruguay?
Offer a terse response. 2.1. 